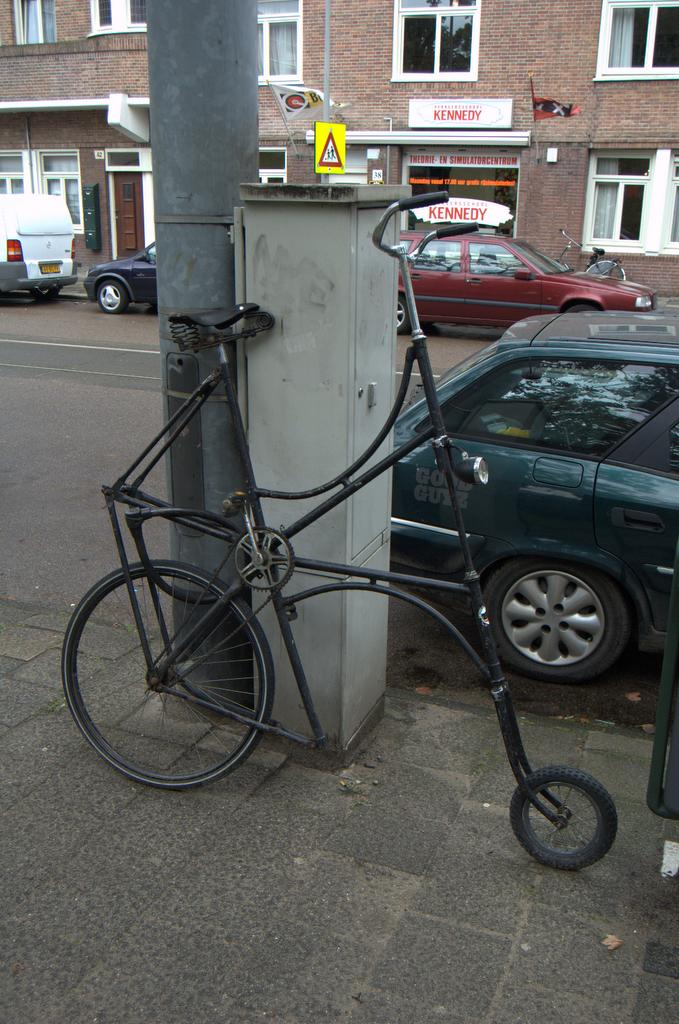What is the main mode of transportation visible in the image? There is a bicycle in the image. What other objects can be seen in the image? There are poles, name boards, vehicles, buildings, windows, curtains, and flags in the image. What type of powder is being used to create the slope in the image? There is no slope or powder present in the image. What noise can be heard coming from the vehicles in the image? The image is static, so no noise can be heard from the vehicles. 